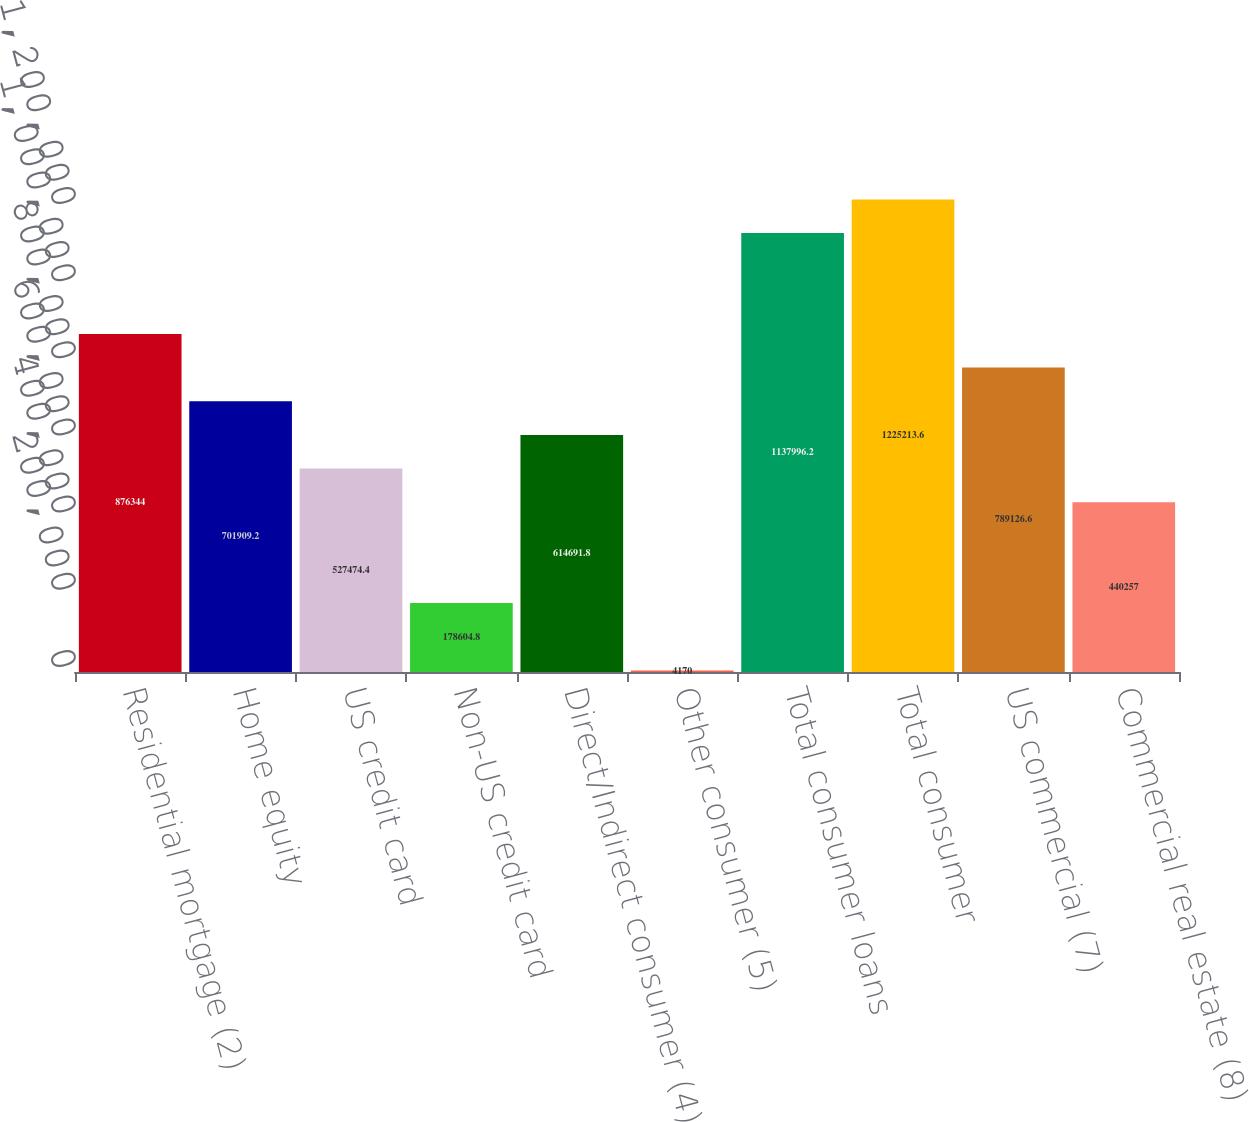<chart> <loc_0><loc_0><loc_500><loc_500><bar_chart><fcel>Residential mortgage (2)<fcel>Home equity<fcel>US credit card<fcel>Non-US credit card<fcel>Direct/Indirect consumer (4)<fcel>Other consumer (5)<fcel>Total consumer loans<fcel>Total consumer<fcel>US commercial (7)<fcel>Commercial real estate (8)<nl><fcel>876344<fcel>701909<fcel>527474<fcel>178605<fcel>614692<fcel>4170<fcel>1.138e+06<fcel>1.22521e+06<fcel>789127<fcel>440257<nl></chart> 